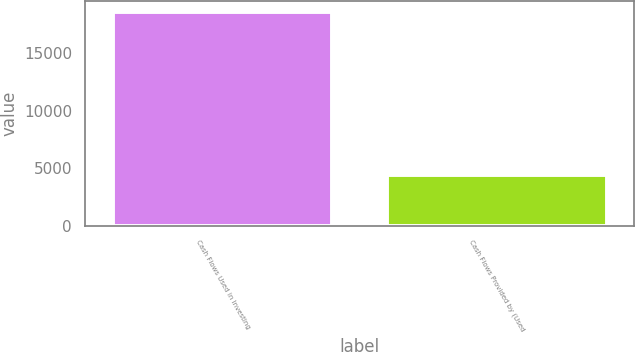Convert chart to OTSL. <chart><loc_0><loc_0><loc_500><loc_500><bar_chart><fcel>Cash Flows Used in Investing<fcel>Cash Flows Provided by (Used<nl><fcel>18579<fcel>4408<nl></chart> 